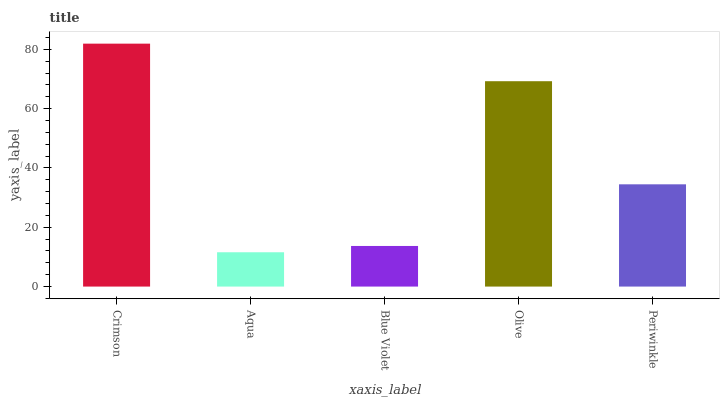Is Aqua the minimum?
Answer yes or no. Yes. Is Crimson the maximum?
Answer yes or no. Yes. Is Blue Violet the minimum?
Answer yes or no. No. Is Blue Violet the maximum?
Answer yes or no. No. Is Blue Violet greater than Aqua?
Answer yes or no. Yes. Is Aqua less than Blue Violet?
Answer yes or no. Yes. Is Aqua greater than Blue Violet?
Answer yes or no. No. Is Blue Violet less than Aqua?
Answer yes or no. No. Is Periwinkle the high median?
Answer yes or no. Yes. Is Periwinkle the low median?
Answer yes or no. Yes. Is Olive the high median?
Answer yes or no. No. Is Blue Violet the low median?
Answer yes or no. No. 